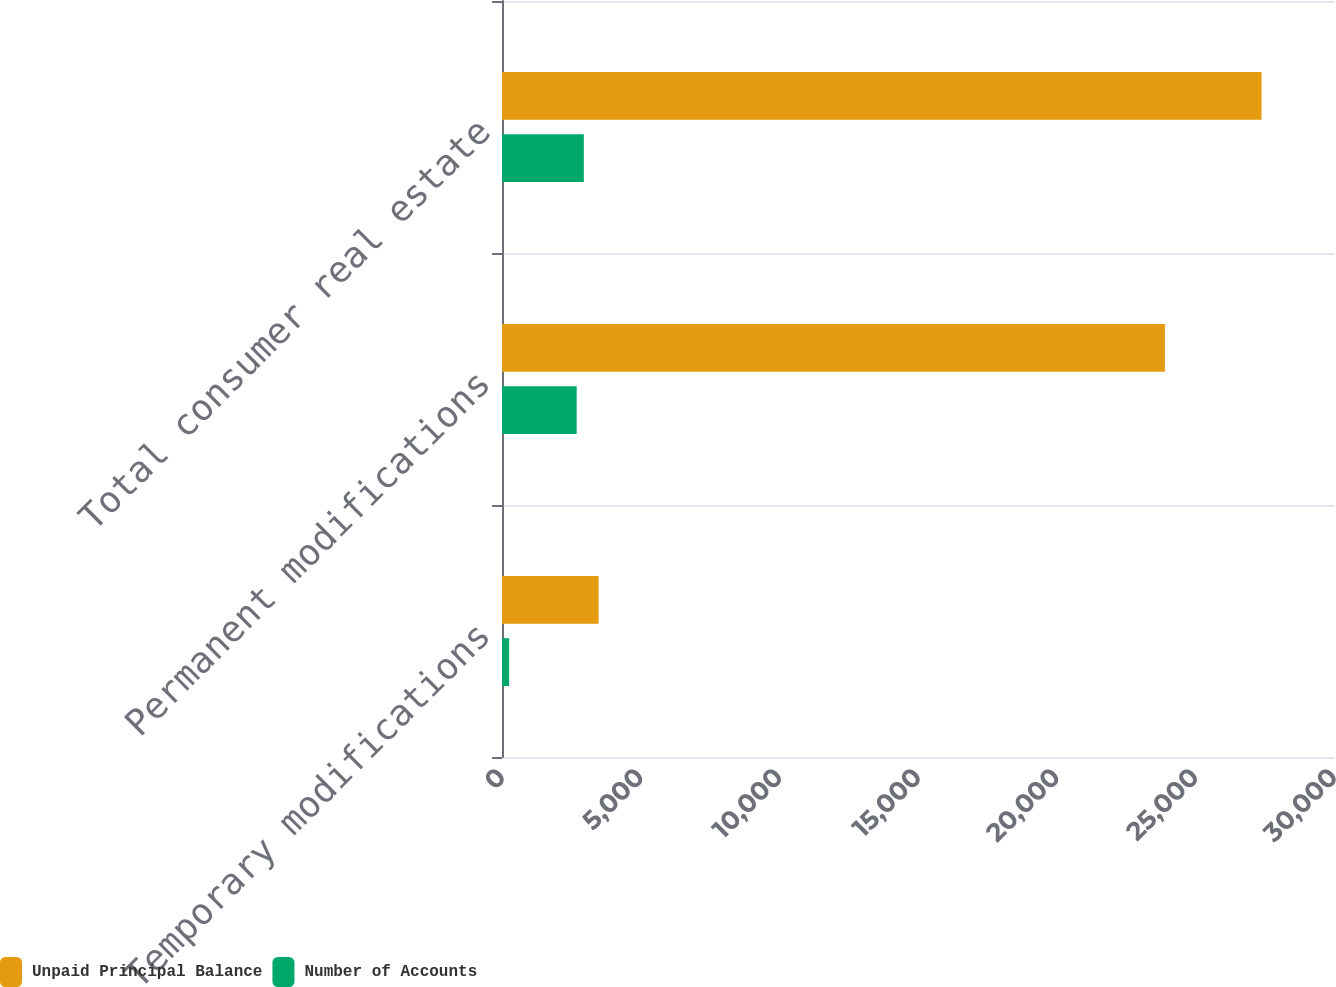<chart> <loc_0><loc_0><loc_500><loc_500><stacked_bar_chart><ecel><fcel>Temporary modifications<fcel>Permanent modifications<fcel>Total consumer real estate<nl><fcel>Unpaid Principal Balance<fcel>3484<fcel>23904<fcel>27388<nl><fcel>Number of Accounts<fcel>258<fcel>2693<fcel>2951<nl></chart> 